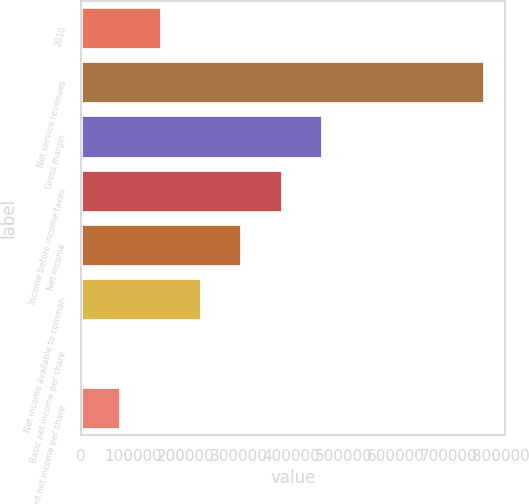Convert chart. <chart><loc_0><loc_0><loc_500><loc_500><bar_chart><fcel>2010<fcel>Net service revenues<fcel>Gross margin<fcel>Income before income taxes<fcel>Net income<fcel>Net income available to common<fcel>Basic net income per share<fcel>Diluted net income per share<nl><fcel>153818<fcel>769090<fcel>461454<fcel>384545<fcel>307636<fcel>230727<fcel>0.08<fcel>76909.1<nl></chart> 